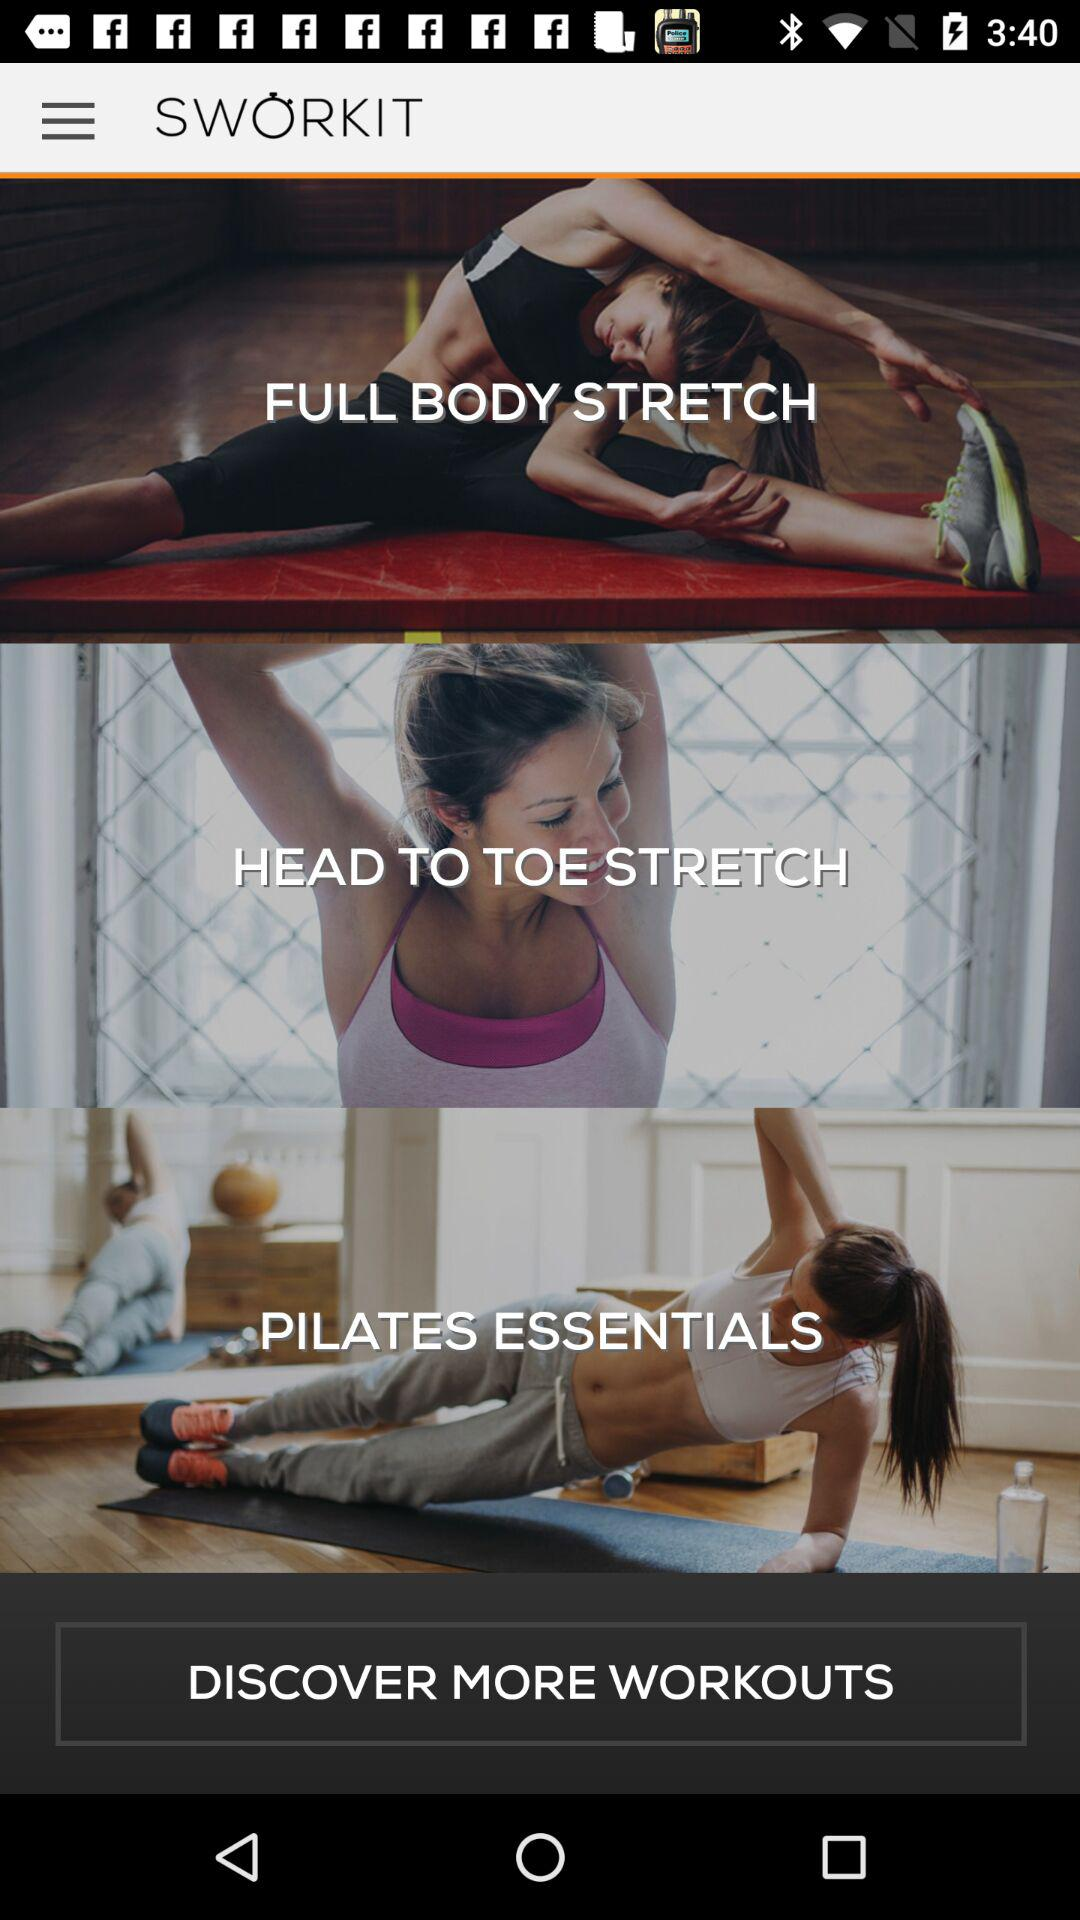What is the name of the application? The name of the application is "SWORKIT". 